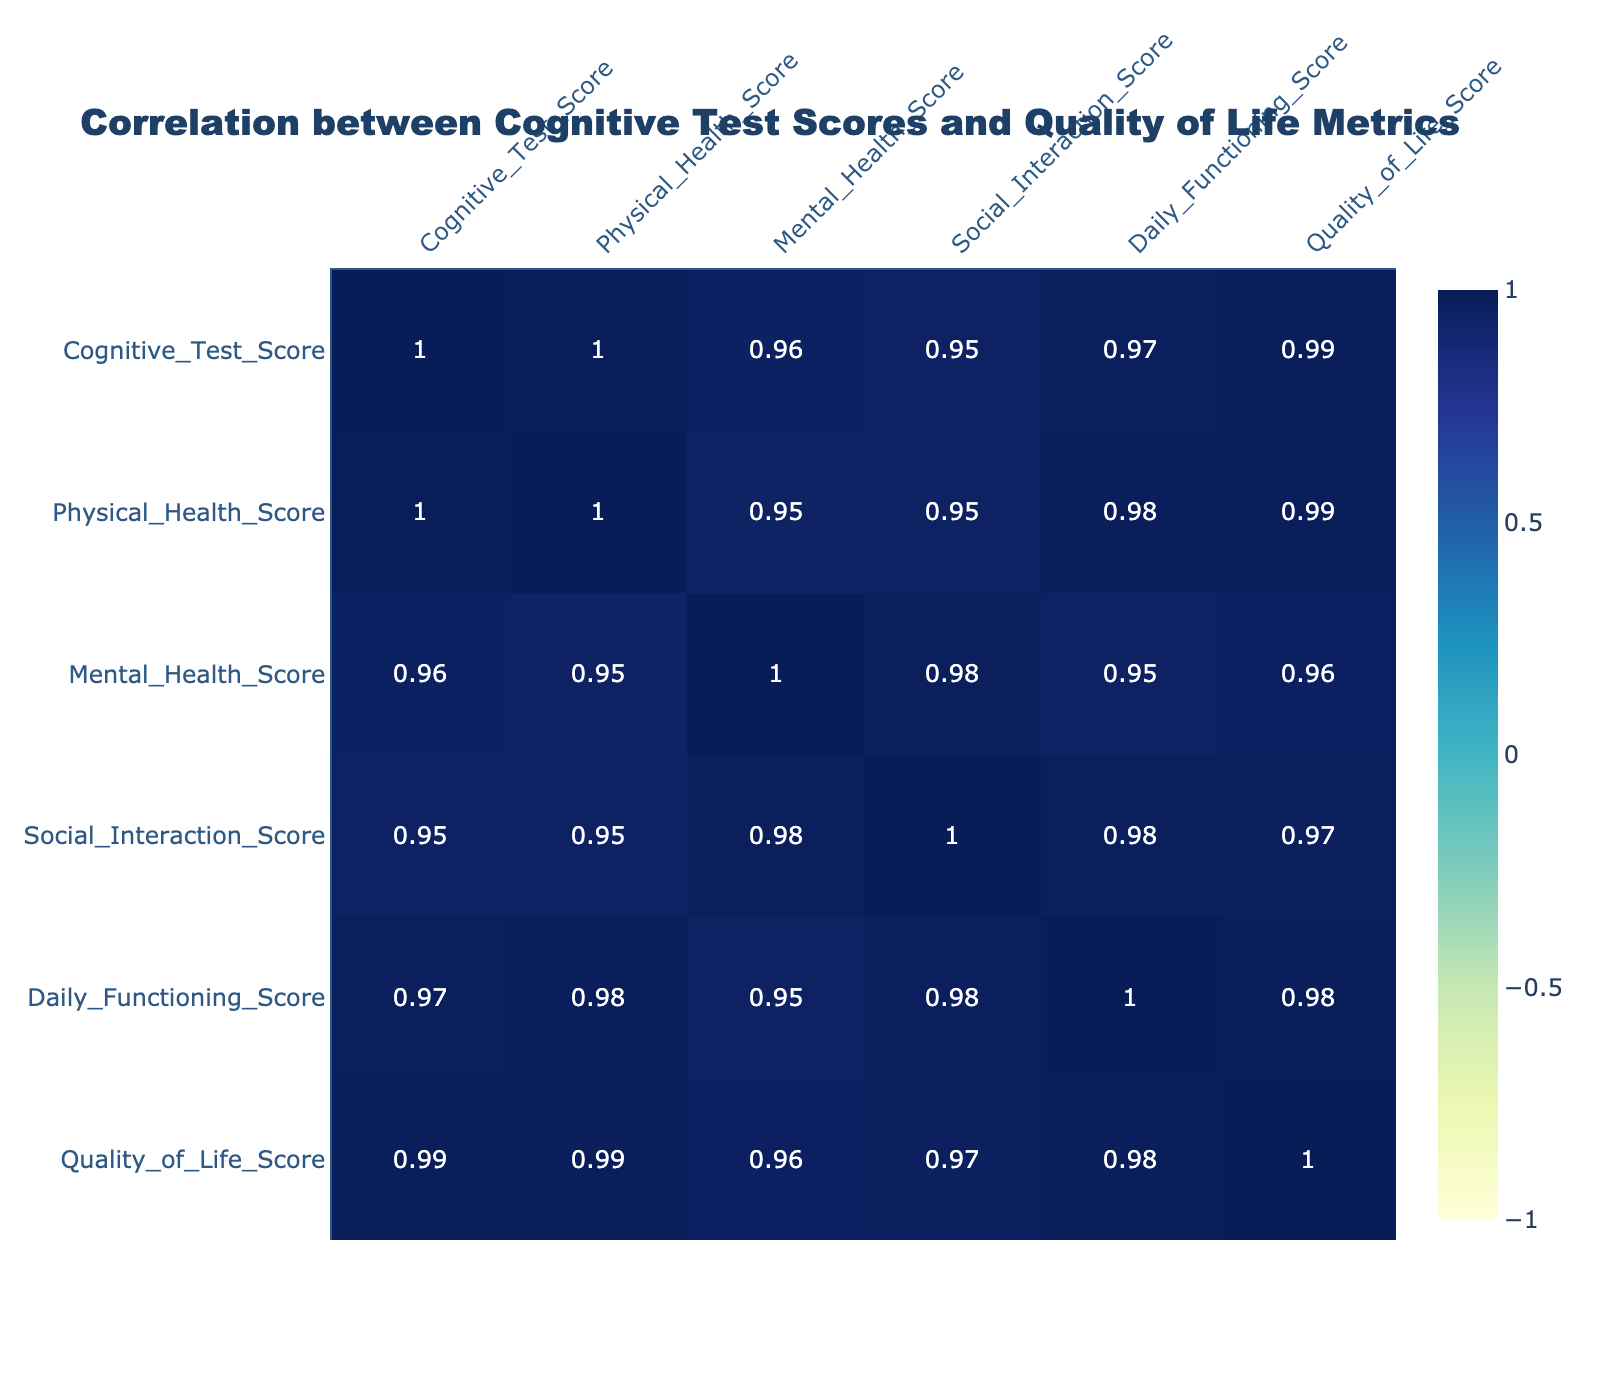What is the correlation coefficient between Cognitive Test Score and Quality of Life Score? According to the correlation table, the correlation coefficient between the Cognitive Test Score and the Quality of Life Score is 0.91, indicating a strong positive relationship.
Answer: 0.91 Which participant had the highest Mental Health Score? The highest Mental Health Score is 92, which belongs to Participant 10.
Answer: Participant 10 What is the average Physical Health Score among all participants? The Physical Health Scores are 78, 80, 65, 50, 85, 60, 80, 70, 40, and 90. The total sum is 78 + 80 + 65 + 50 + 85 + 60 + 80 + 70 + 40 + 90 =  828, and there are 10 participants, resulting in an average score of 828/10, which equals 82.8.
Answer: 82.8 Is there a positive correlation between Daily Functioning Score and Social Interaction Score? Yes, the correlation coefficient between Daily Functioning Score and Social Interaction Score is 0.73, which indicates a positive correlation.
Answer: Yes What is the difference between the highest and lowest Quality of Life Scores? The highest Quality of Life Score is 95 from Participant 10, and the lowest is 42 from Participant 9. The difference is calculated as 95 - 42 = 53.
Answer: 53 What proportion of participants reported a Quality of Life Score above 80? There are 10 participants in total. The participants with Quality of Life Scores above 80 are Participant 1 (82), Participant 2 (84), Participant 5 (90), Participant 7 (88), and Participant 10 (95). That makes 5 participants, so the proportion is 5/10 = 0.5.
Answer: 0.5 Which score has the least correlation with the Cognitive Test Score? The correlation coefficients with the Cognitive Test Score are: Physical Health Score (0.66), Mental Health Score (0.83), Social Interaction Score (0.53), Daily Functioning Score (0.86). The least correlation is with the Social Interaction Score, which is 0.53.
Answer: Social Interaction Score How many participants scored below the median in Daily Functioning Score? The Daily Functioning Scores are 90, 85, 70, 50, 95, 70, 92, 75, 45, and 97. The total number of scores is 10, so the median is the average of the 5th and 6th scores in sorted order, which are 70 and 75. The median is (70 + 75)/2 = 72.5. The participants with scores below 72.5 are Participants 4 and 9, totaling 2 participants.
Answer: 2 What is the relationship between the Physical Health Score and the Mental Health Score? The correlation coefficient between the Physical Health Score and the Mental Health Score is 0.72, indicating a strong positive relationship.
Answer: 0.72 